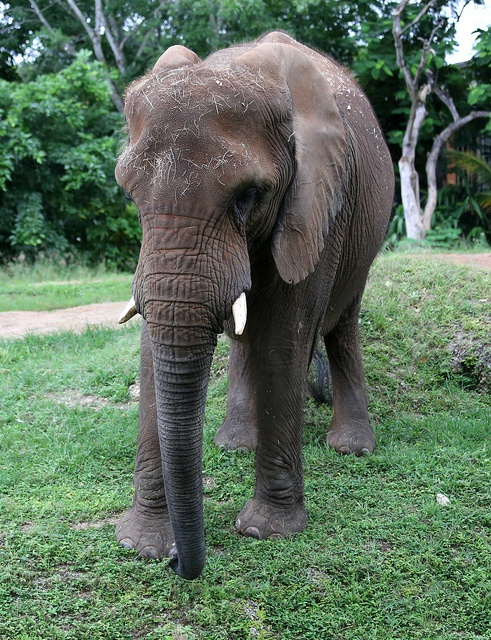Describe the objects in this image and their specific colors. I can see a elephant in black, gray, and darkgray tones in this image. 